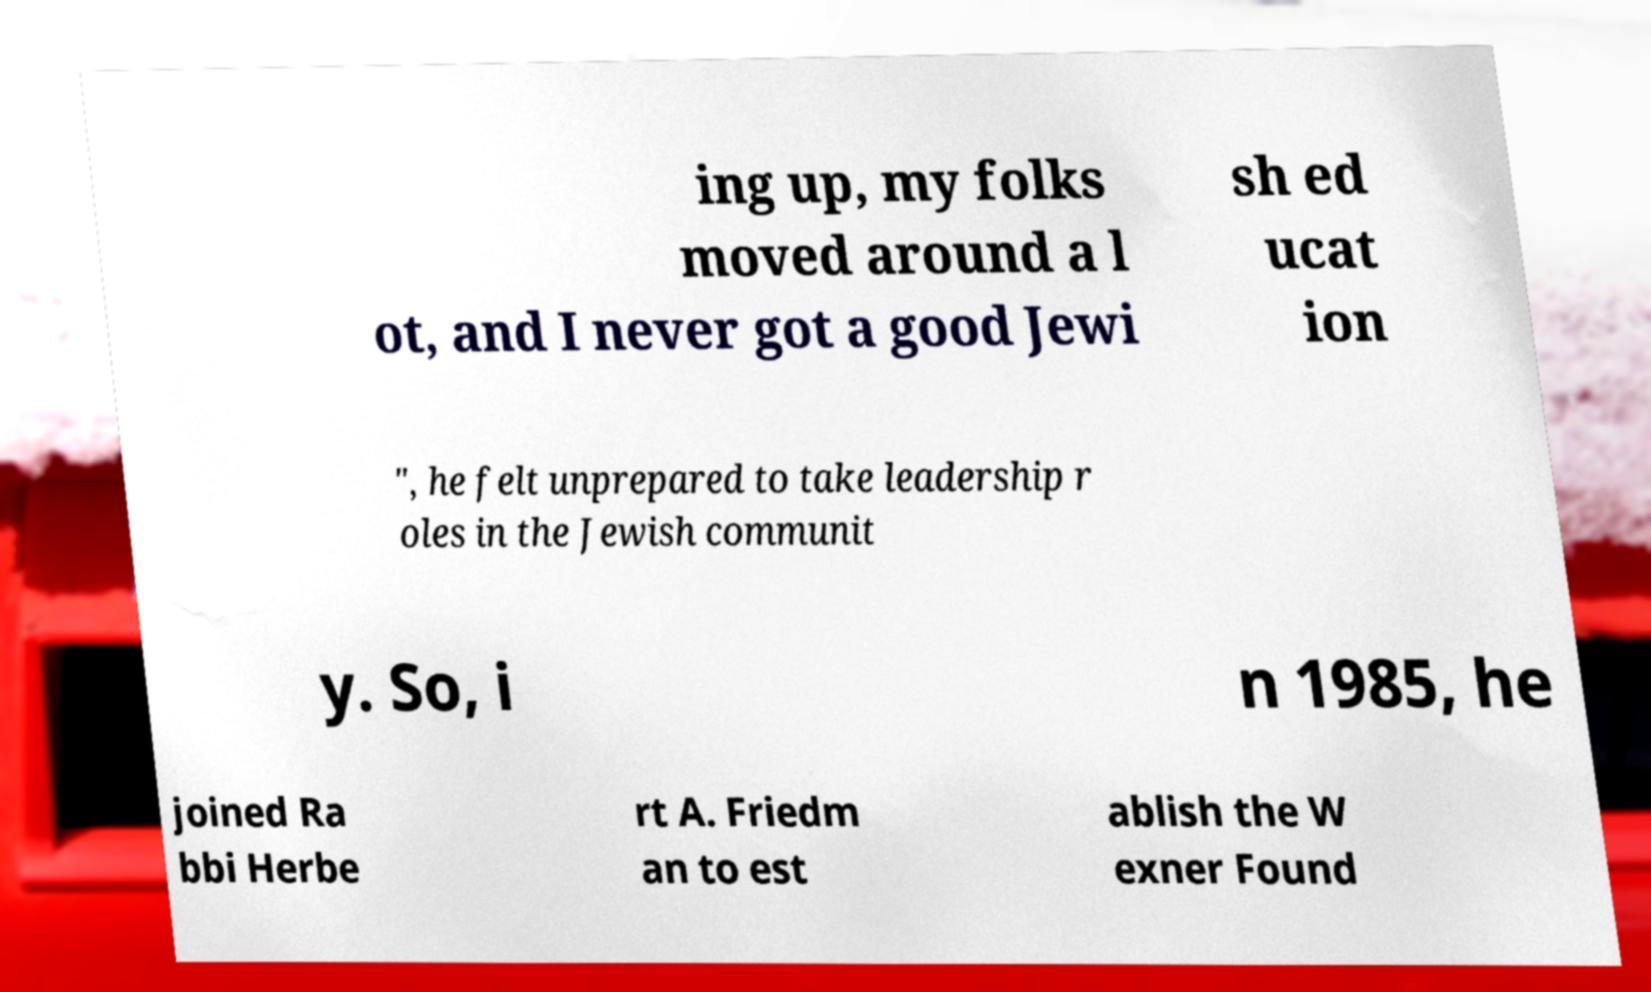What messages or text are displayed in this image? I need them in a readable, typed format. ing up, my folks moved around a l ot, and I never got a good Jewi sh ed ucat ion ", he felt unprepared to take leadership r oles in the Jewish communit y. So, i n 1985, he joined Ra bbi Herbe rt A. Friedm an to est ablish the W exner Found 